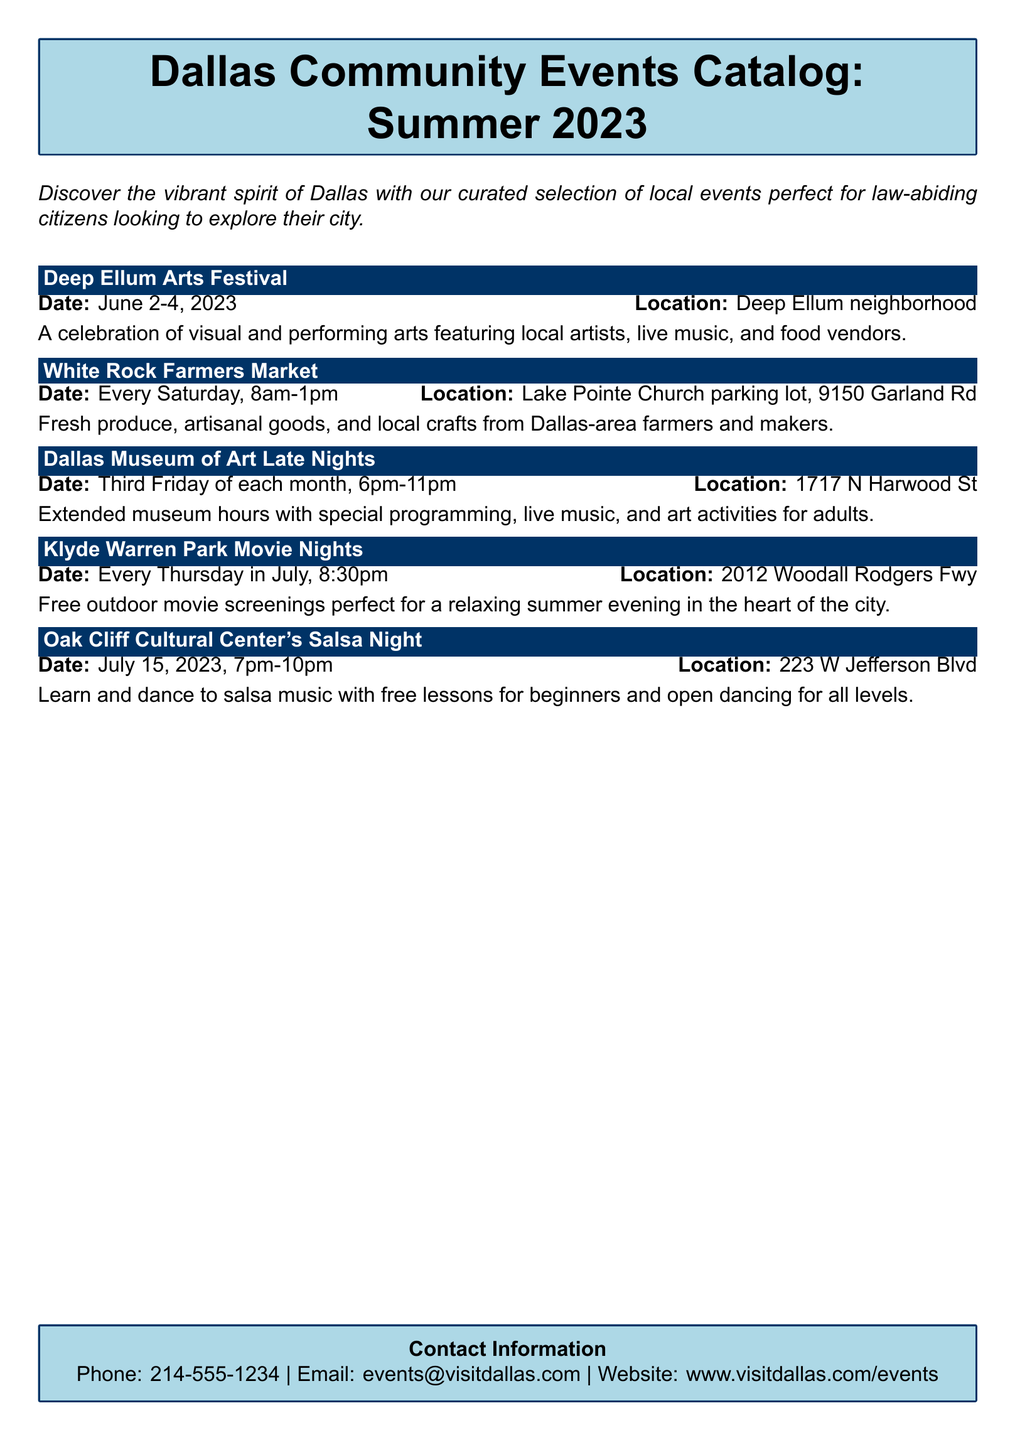What is the date range for the Deep Ellum Arts Festival? The festival's date is explicitly mentioned in the document as June 2-4, 2023.
Answer: June 2-4, 2023 Where is the White Rock Farmers Market held? The location of the farmers market is provided in the document as the Lake Pointe Church parking lot, 9150 Garland Rd.
Answer: Lake Pointe Church parking lot, 9150 Garland Rd What type of event is held every Thursday in July? The document specifies that free outdoor movie screenings are conducted every Thursday in July.
Answer: Free outdoor movie screenings When does the Dallas Museum of Art Late Nights event occur? The document states that the event happens on the third Friday of each month.
Answer: Third Friday of each month What is the main activity at Oak Cliff Cultural Center's Salsa Night? The main activity described in the document is learning and dancing to salsa music.
Answer: Learning and dancing to salsa music How many events are listed in the catalog? The document lists a total of five distinct events.
Answer: Five What is the contact phone number provided in the catalog? The phone number for contact is mentioned as 214-555-1234.
Answer: 214-555-1234 What kind of goods can one find at the White Rock Farmers Market? The document cites fresh produce, artisanal goods, and local crafts as the types of goods available.
Answer: Fresh produce, artisanal goods, and local crafts What day is Salsa Night scheduled for? The document states that Salsa Night is scheduled for July 15, 2023.
Answer: July 15, 2023 